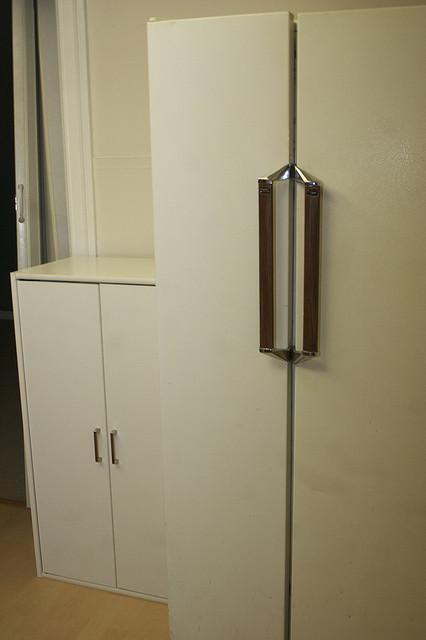How many handles are shown?
Be succinct. 4. Does the walls have wallpaper?
Quick response, please. No. Are the doors of the cabinet closed?
Write a very short answer. Yes. What color are the cabinets?
Write a very short answer. White. Is there a carpet on the floor?
Keep it brief. No. 